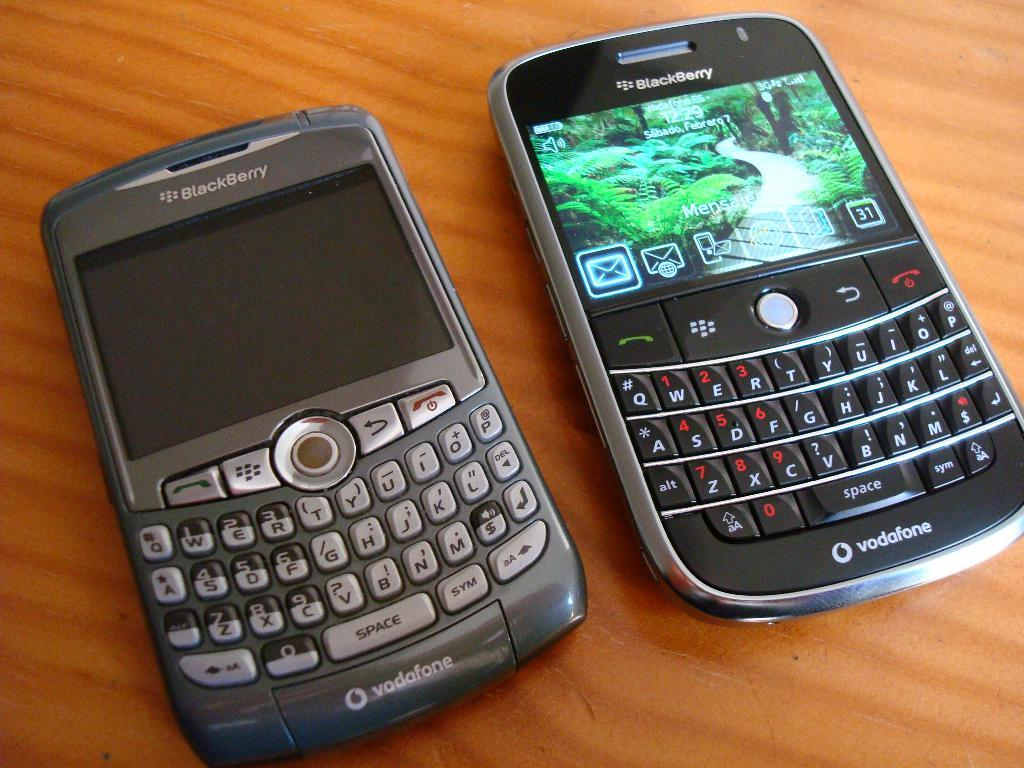How many mobiles are visible on the table in the image? There are two mobiles on the table in the image. Can you describe the lighting conditions in the image? The image was likely taken during the day, as the lighting appears to be natural and bright. What type of root can be seen growing in the yard in the image? There is no yard or root present in the image; it only features two mobiles on a table. 